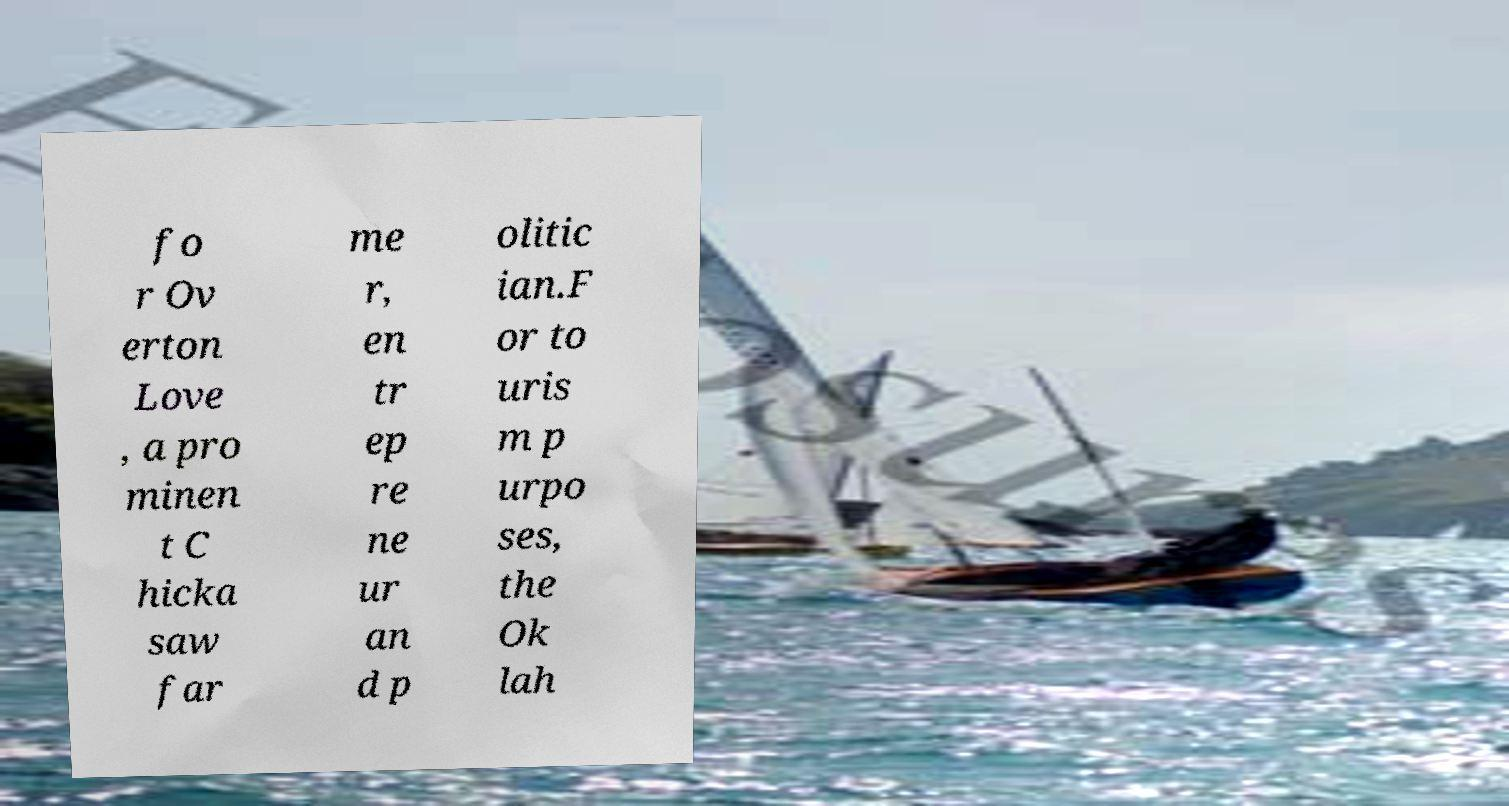Can you accurately transcribe the text from the provided image for me? fo r Ov erton Love , a pro minen t C hicka saw far me r, en tr ep re ne ur an d p olitic ian.F or to uris m p urpo ses, the Ok lah 